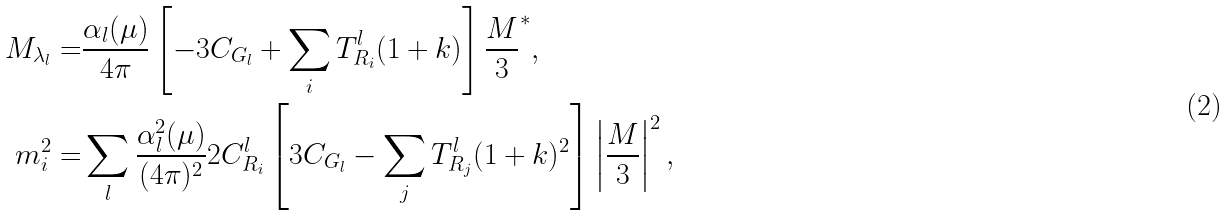<formula> <loc_0><loc_0><loc_500><loc_500>M _ { \lambda _ { l } } = & \frac { \alpha _ { l } ( \mu ) } { 4 \pi } \left [ - 3 C _ { G _ { l } } + \sum _ { i } T ^ { l } _ { R _ { i } } ( 1 + k ) \right ] \frac { M } { 3 } ^ { * } , \\ m ^ { 2 } _ { i } = & \sum _ { l } \frac { \alpha _ { l } ^ { 2 } ( \mu ) } { ( 4 \pi ) ^ { 2 } } 2 C ^ { l } _ { R _ { i } } \left [ 3 C _ { G _ { l } } - \sum _ { j } T ^ { l } _ { R _ { j } } ( 1 + k ) ^ { 2 } \right ] \left | \frac { M } { 3 } \right | ^ { 2 } ,</formula> 